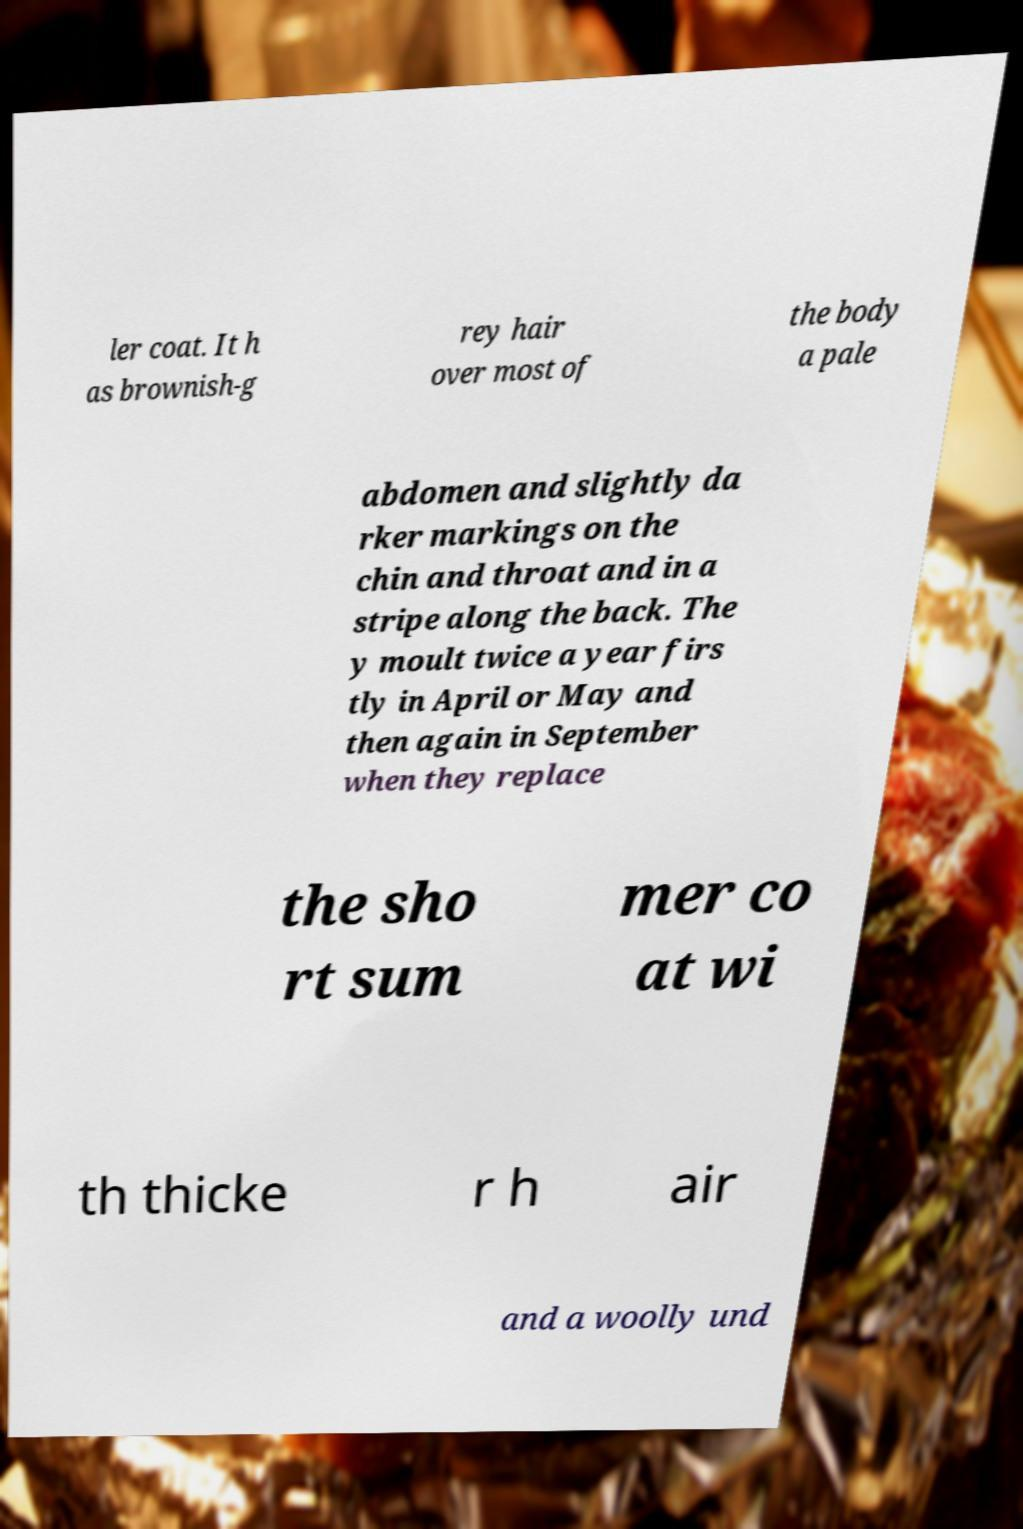There's text embedded in this image that I need extracted. Can you transcribe it verbatim? ler coat. It h as brownish-g rey hair over most of the body a pale abdomen and slightly da rker markings on the chin and throat and in a stripe along the back. The y moult twice a year firs tly in April or May and then again in September when they replace the sho rt sum mer co at wi th thicke r h air and a woolly und 